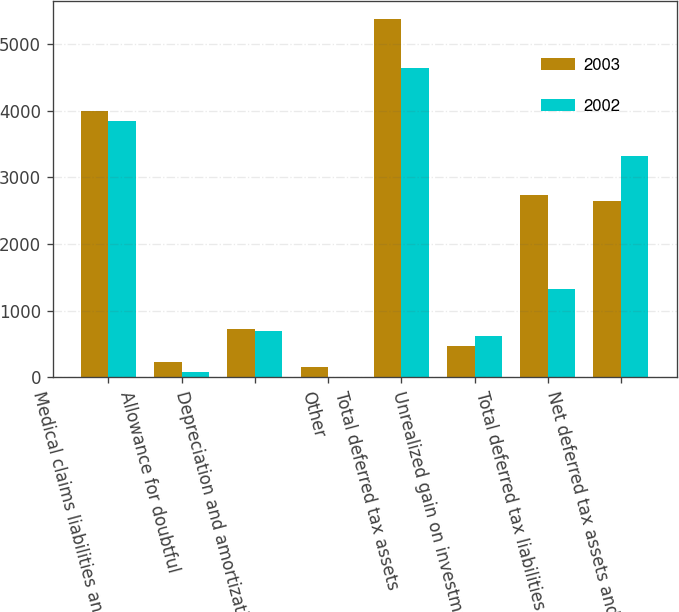Convert chart to OTSL. <chart><loc_0><loc_0><loc_500><loc_500><stacked_bar_chart><ecel><fcel>Medical claims liabilities and<fcel>Allowance for doubtful<fcel>Depreciation and amortization<fcel>Other<fcel>Total deferred tax assets<fcel>Unrealized gain on investments<fcel>Total deferred tax liabilities<fcel>Net deferred tax assets and<nl><fcel>2003<fcel>3992<fcel>230<fcel>720<fcel>156<fcel>5377<fcel>472<fcel>2735<fcel>2642<nl><fcel>2002<fcel>3848<fcel>81<fcel>702<fcel>8<fcel>4639<fcel>618<fcel>1321<fcel>3318<nl></chart> 